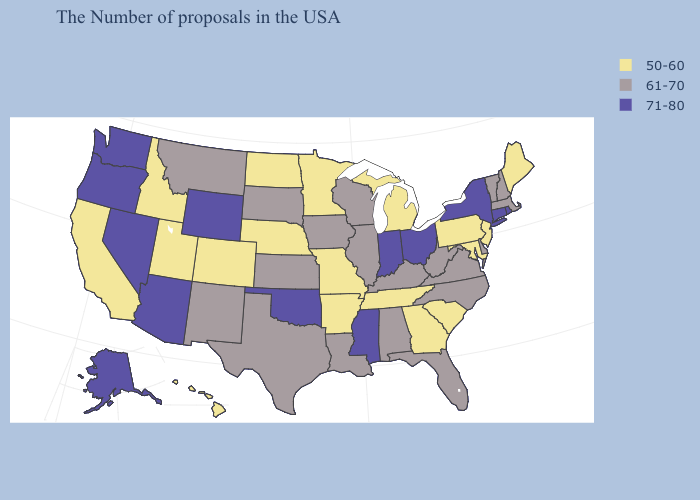Name the states that have a value in the range 61-70?
Quick response, please. Massachusetts, New Hampshire, Vermont, Delaware, Virginia, North Carolina, West Virginia, Florida, Kentucky, Alabama, Wisconsin, Illinois, Louisiana, Iowa, Kansas, Texas, South Dakota, New Mexico, Montana. Name the states that have a value in the range 71-80?
Keep it brief. Rhode Island, Connecticut, New York, Ohio, Indiana, Mississippi, Oklahoma, Wyoming, Arizona, Nevada, Washington, Oregon, Alaska. Name the states that have a value in the range 50-60?
Keep it brief. Maine, New Jersey, Maryland, Pennsylvania, South Carolina, Georgia, Michigan, Tennessee, Missouri, Arkansas, Minnesota, Nebraska, North Dakota, Colorado, Utah, Idaho, California, Hawaii. Does New Jersey have a higher value than Mississippi?
Answer briefly. No. Name the states that have a value in the range 71-80?
Concise answer only. Rhode Island, Connecticut, New York, Ohio, Indiana, Mississippi, Oklahoma, Wyoming, Arizona, Nevada, Washington, Oregon, Alaska. What is the value of Massachusetts?
Be succinct. 61-70. Which states have the lowest value in the USA?
Quick response, please. Maine, New Jersey, Maryland, Pennsylvania, South Carolina, Georgia, Michigan, Tennessee, Missouri, Arkansas, Minnesota, Nebraska, North Dakota, Colorado, Utah, Idaho, California, Hawaii. Among the states that border Illinois , does Kentucky have the lowest value?
Quick response, please. No. What is the value of Colorado?
Answer briefly. 50-60. What is the value of Indiana?
Short answer required. 71-80. Name the states that have a value in the range 61-70?
Quick response, please. Massachusetts, New Hampshire, Vermont, Delaware, Virginia, North Carolina, West Virginia, Florida, Kentucky, Alabama, Wisconsin, Illinois, Louisiana, Iowa, Kansas, Texas, South Dakota, New Mexico, Montana. Name the states that have a value in the range 71-80?
Be succinct. Rhode Island, Connecticut, New York, Ohio, Indiana, Mississippi, Oklahoma, Wyoming, Arizona, Nevada, Washington, Oregon, Alaska. What is the lowest value in states that border South Carolina?
Concise answer only. 50-60. Name the states that have a value in the range 71-80?
Write a very short answer. Rhode Island, Connecticut, New York, Ohio, Indiana, Mississippi, Oklahoma, Wyoming, Arizona, Nevada, Washington, Oregon, Alaska. Does Maine have the same value as Pennsylvania?
Give a very brief answer. Yes. 